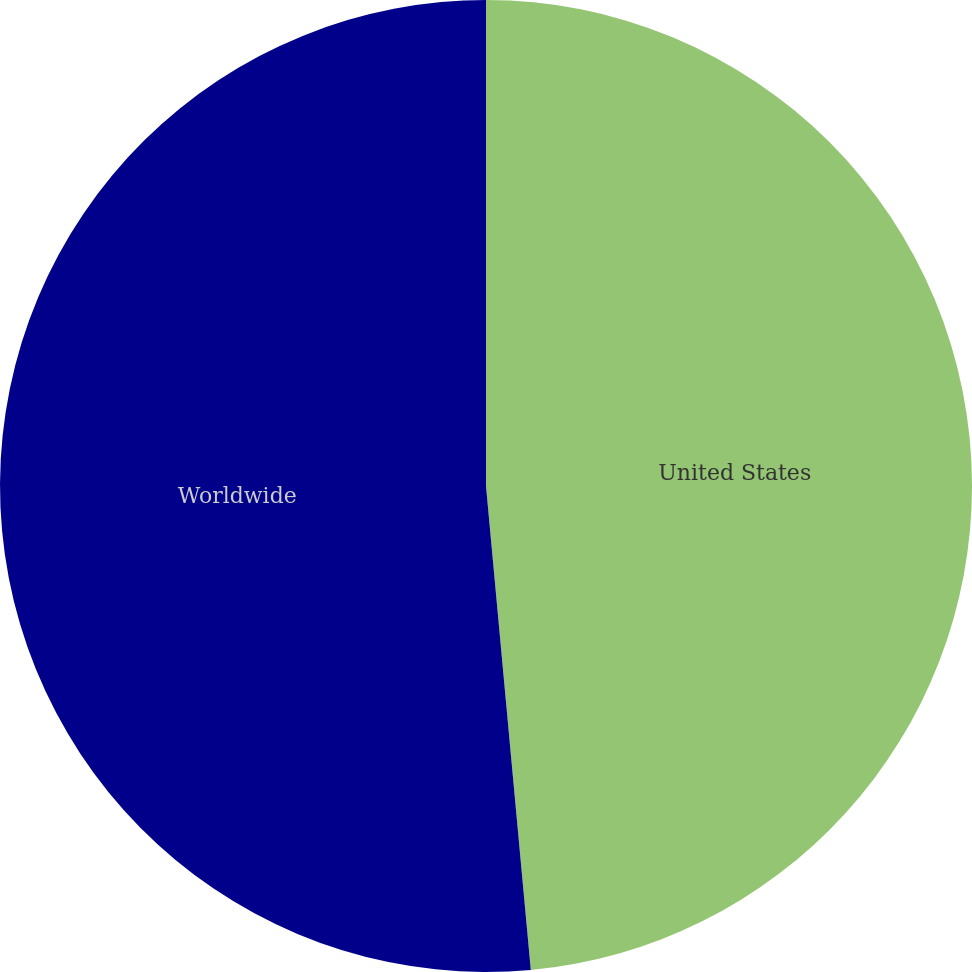<chart> <loc_0><loc_0><loc_500><loc_500><pie_chart><fcel>United States<fcel>Worldwide<nl><fcel>48.53%<fcel>51.47%<nl></chart> 